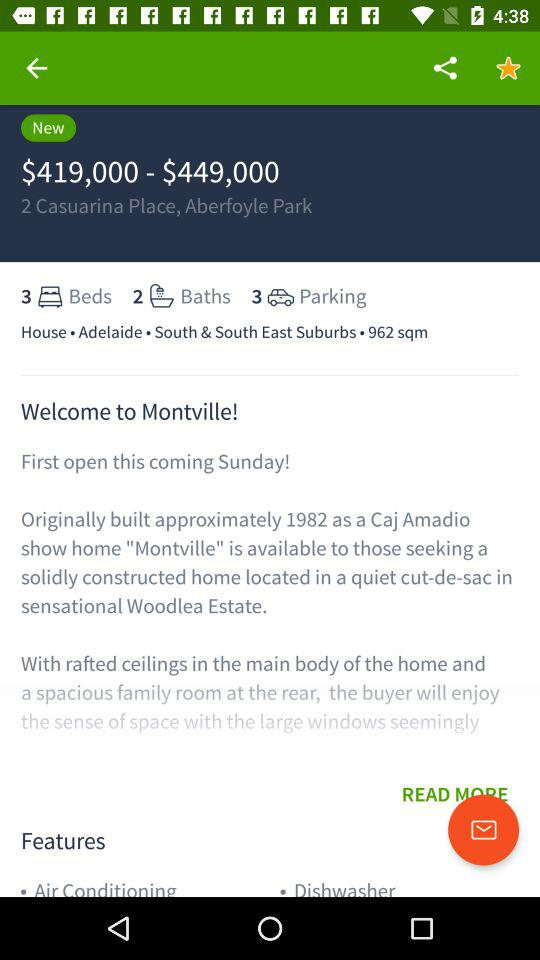How many more bedrooms than bathrooms does the property have?
Answer the question using a single word or phrase. 1 